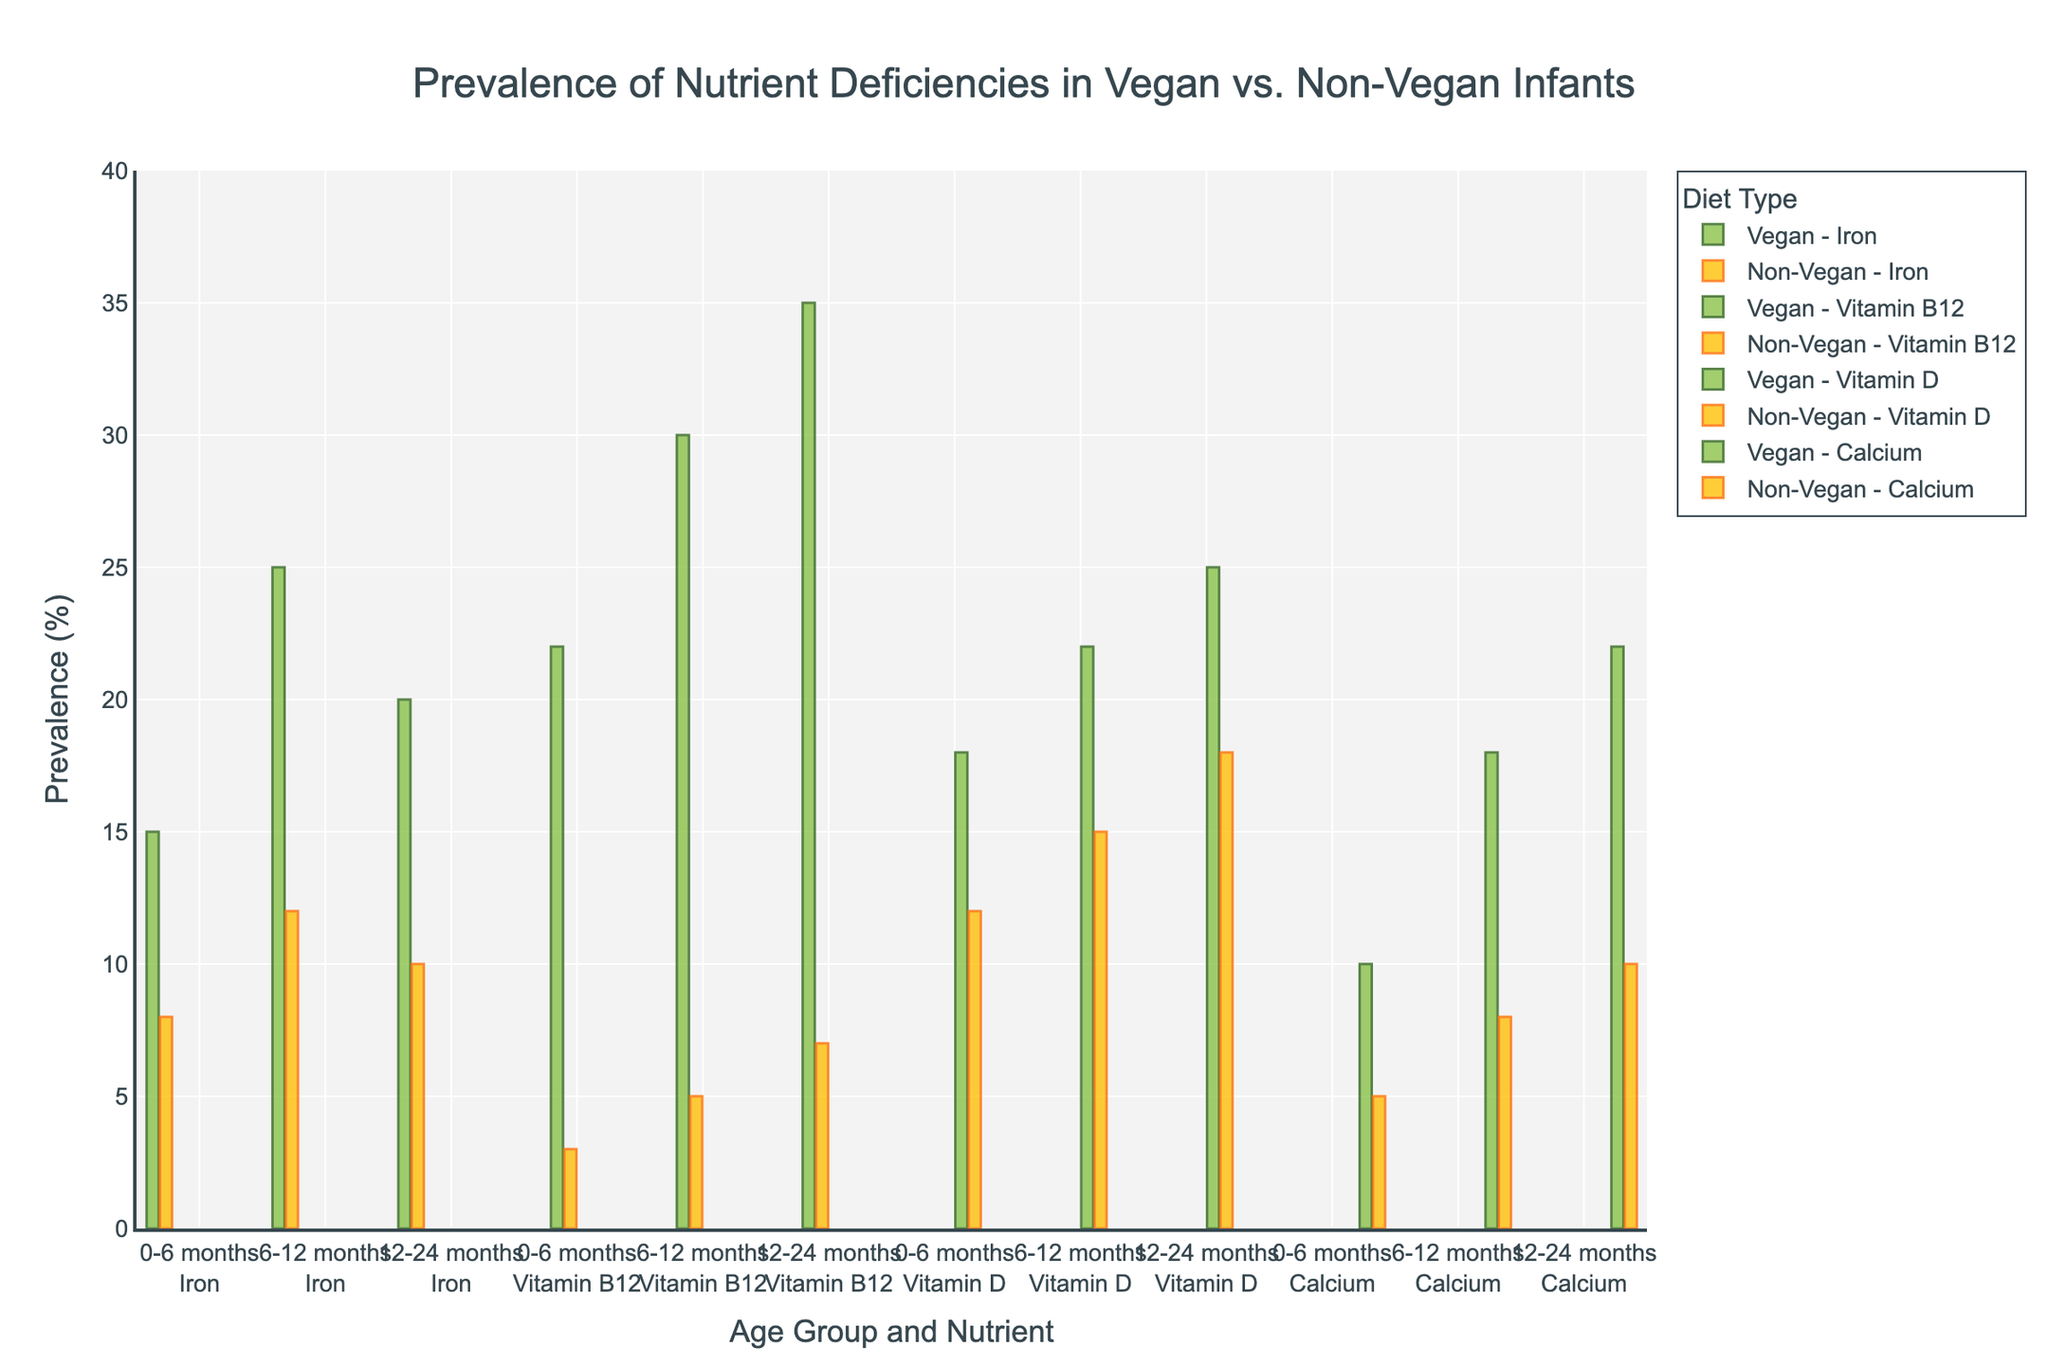Which nutrient deficiency is more prevalent among vegan infants in the 6-12 months age group compared to non-vegan infants? The bar chart shows that for the 6-12 months age group, Vitamin B12 deficiency is significantly more prevalent among vegan infants (30%) compared to non-vegan infants (5%).
Answer: Vitamin B12 Which age group shows the highest prevalence of iron deficiency among vegan infants? By observing the bar heights for iron deficiency across different age groups for vegan infants, the 6-12 months age group has the highest bar, indicating a prevalence of 25%.
Answer: 6-12 months Compare the prevalence of calcium deficiency between vegan and non-vegan infants in the 12-24 months age group. For the 12-24 months age group, the bar for calcium deficiency is higher for vegan infants (22%) than for non-vegan infants (10%).
Answer: Vegan: 22%, Non-Vegan: 10% What is the difference in prevalence of Vitamin D deficiency between vegan and non-vegan infants in the 0-6 months age group? The bar height shows that the prevalence of Vitamin D deficiency in vegan infants is 18%, while in non-vegan infants it is 12%. The difference is 18% - 12% = 6%.
Answer: 6% Which nutrient shows the smallest difference in deficiency prevalence between vegan and non-vegan infants in the 6-12 months age group? By comparing the bar heights, Calcium has the smallest difference in deficiency prevalence between vegan (18%) and non-vegan (8%) infants, which is 10%.
Answer: Calcium What is the average prevalence of Vitamin B12 deficiency among vegan infants across all age groups? The prevalence of Vitamin B12 deficiency in vegan infants is 22%, 30%, and 35% for 0-6, 6-12, and 12-24 months respectively. The average is (22% + 30% + 35%) / 3 = 87% / 3 = 29%.
Answer: 29% What do the bar colors represent in the chart? The green bars represent nutrient deficiencies in vegan infants, whereas the yellow bars represent nutrient deficiencies in non-vegan infants.
Answer: Nutrient deficiencies in vegan (green) and non-vegan (yellow) infants 